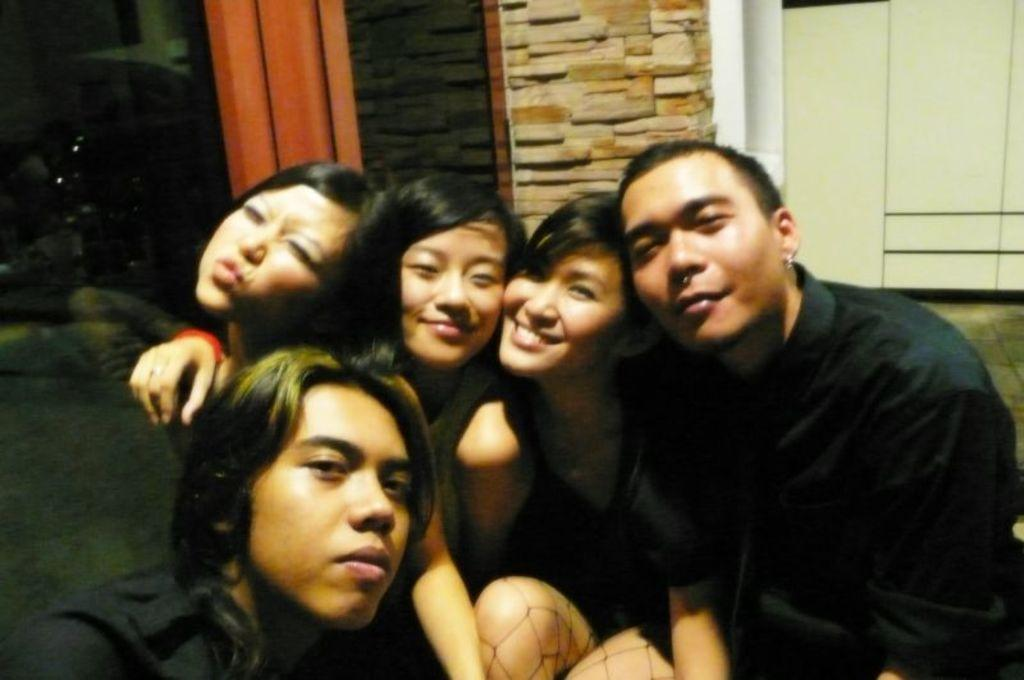What can be seen in the image? There is a group of people in the image. What is visible in the background of the image? Walls are visible in the background of the image. What is the surface on which the people are standing? There is a floor visible in the image. What type of sheet is being used by the fireman in the image? There is no fireman or sheet present in the image. 